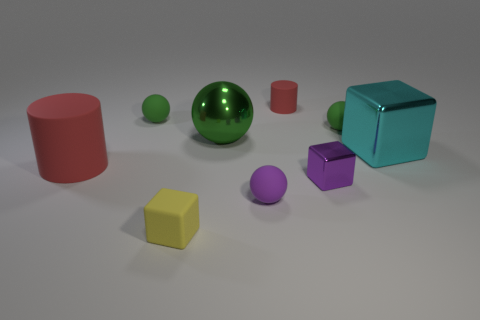Is the number of yellow objects greater than the number of small yellow shiny cylinders?
Offer a very short reply. Yes. Are there any things?
Your response must be concise. Yes. What number of objects are big objects to the right of the small red cylinder or green spheres to the right of the small yellow matte thing?
Offer a very short reply. 3. Does the small metallic block have the same color as the small cylinder?
Ensure brevity in your answer.  No. Is the number of big brown shiny cubes less than the number of matte objects?
Provide a short and direct response. Yes. Are there any green balls behind the small shiny block?
Offer a terse response. Yes. Is the small purple sphere made of the same material as the tiny cylinder?
Your answer should be very brief. Yes. The tiny metallic object that is the same shape as the small yellow matte thing is what color?
Provide a succinct answer. Purple. Do the big thing that is on the right side of the purple matte sphere and the big matte cylinder have the same color?
Make the answer very short. No. What is the shape of the tiny object that is the same color as the tiny shiny cube?
Keep it short and to the point. Sphere. 